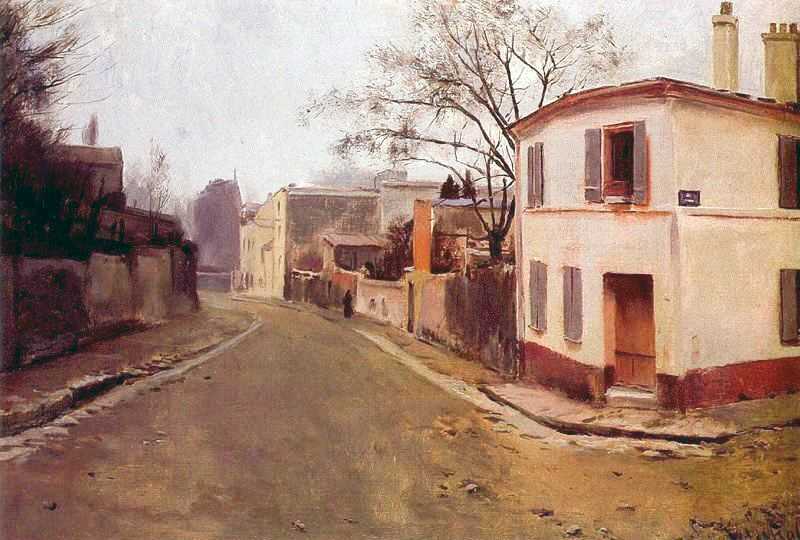If the street could speak, what stories would it tell about the people who lived here? If the street could speak, it would tell tales of the many lives that have intersected here over the decades. It would recount the laughter and joy of children playing, the whispered secrets of young lovers walking hand in hand, and the weary steps of workers returning home after a long day. The street has seen celebrations of festivals and parades, moments of quiet reflection during tough times, and the daily routines that knit the community together. It would tell stories of friendships formed, dreams pursued, and the comforting constancy of life in a small town. Each stone and brick would have tales of resilience, love, and the simple beauty of everyday life. 